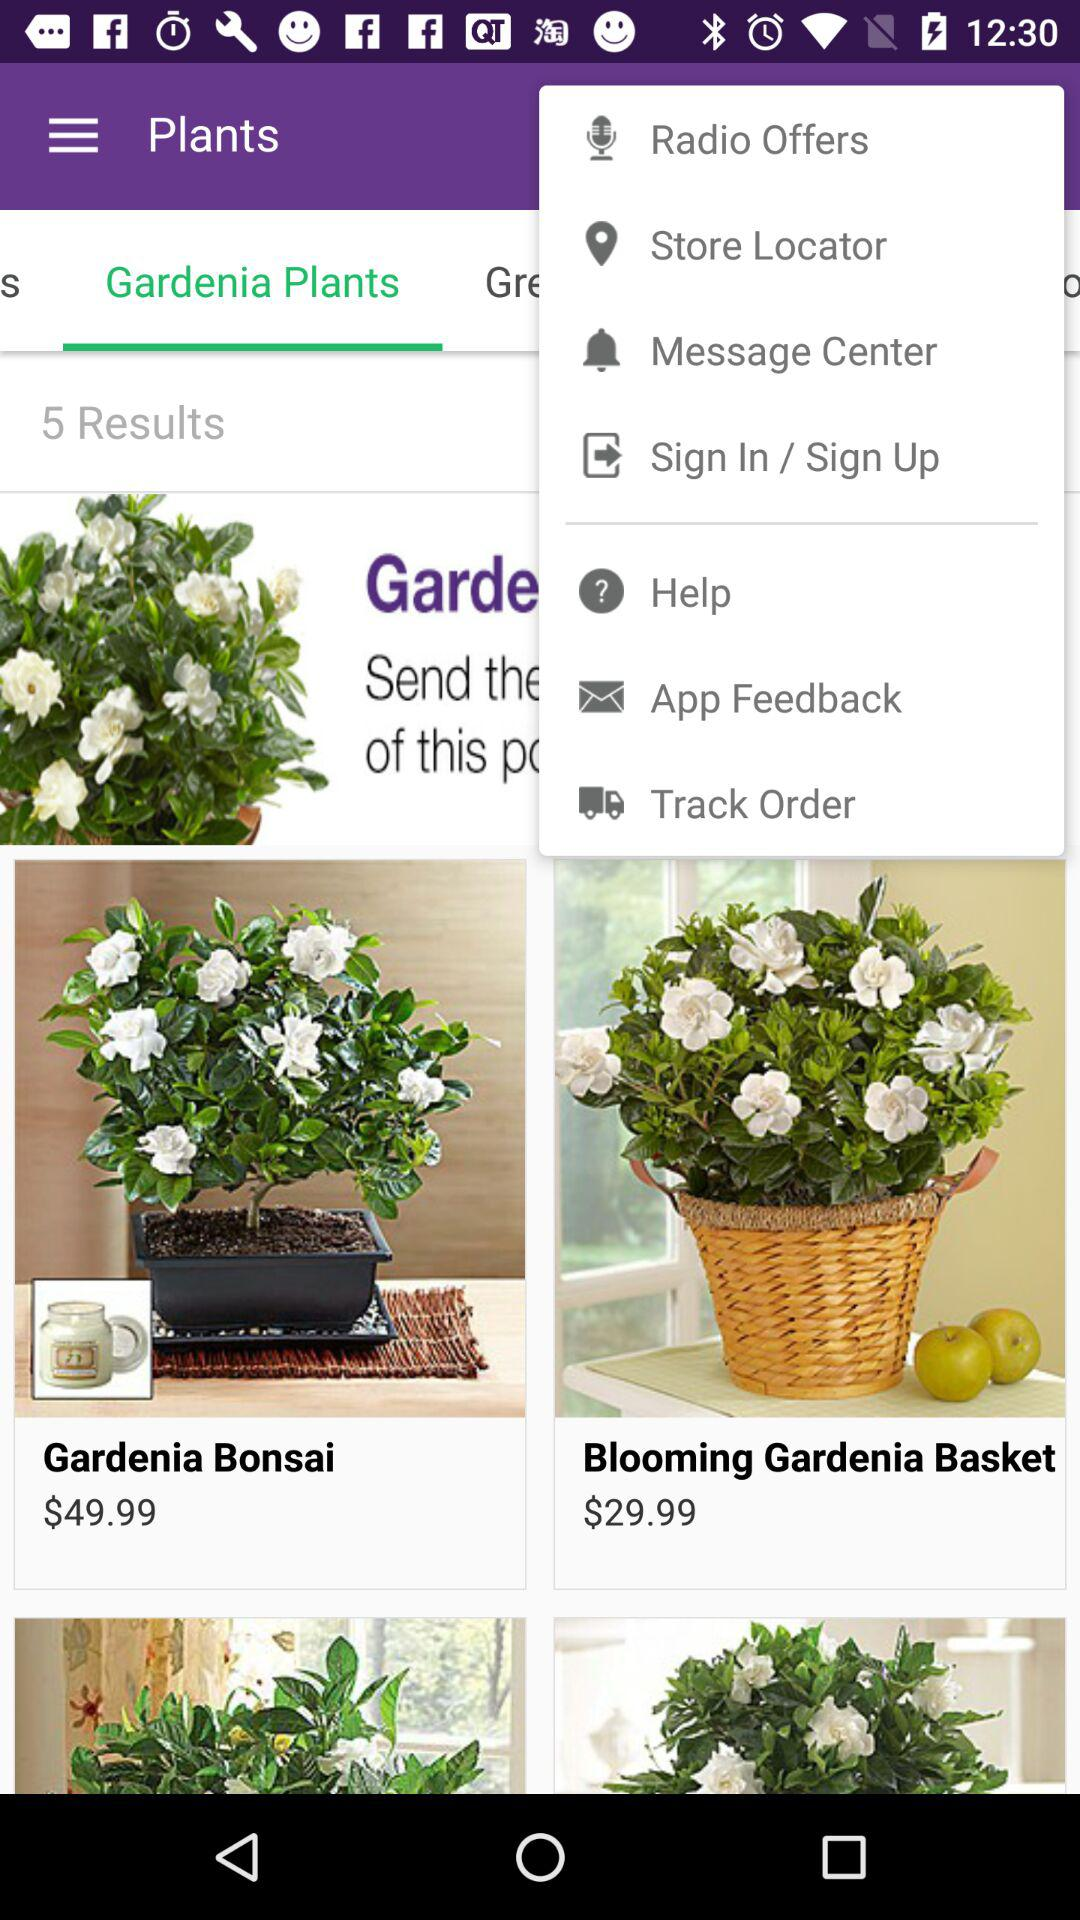What is the price of "Gardenia Bonsai"? The price is $49.99. 